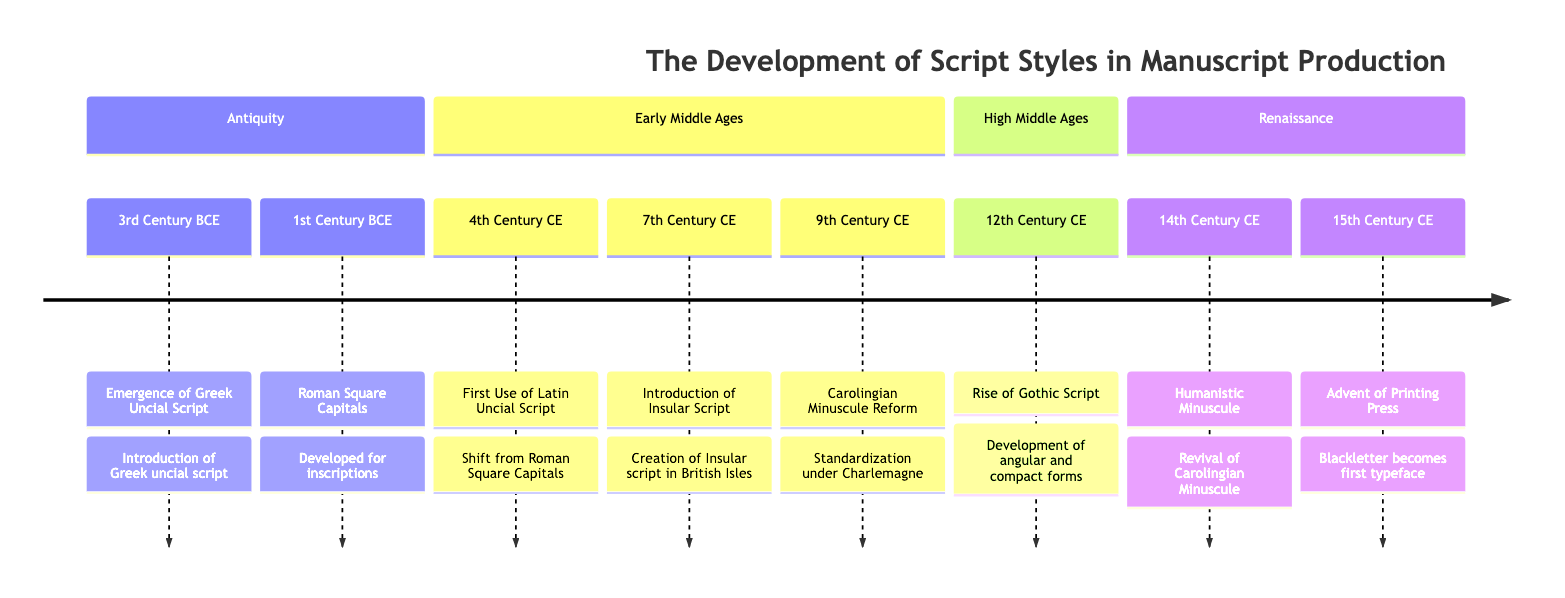What is the earliest script style mentioned in the timeline? The timeline lists the emergence of Greek Uncial Script in the 3rd Century BCE as the earliest event in the timeline. This can be confirmed by locating the earliest period in the timeline and reading the associated event.
Answer: Greek Uncial Script Which century does the Carolingian Minuscule Reform occur? The timeline identifies the Carolingian Minuscule Reform happening in the 9th Century CE. By scanning the events in the Early Middle Ages section, we find this specific event corresponds to that century.
Answer: 9th Century CE What type of script is prevalent during the High Middle Ages? The Rise of Gothic Script is the event that represents the prevalent script style during the High Middle Ages, as indicated in that section of the timeline.
Answer: Gothic Script How many major sections are there in the timeline? The timeline is divided into four major sections: Antiquity, Early Middle Ages, High Middle Ages, and Renaissance. Counting these sections provides the answer.
Answer: 4 What is the script style that led to modern Latin typefaces? According to the timeline, Humanistic Minuscule is identified as the script that is the basis for modern Latin typefaces during the Renaissance period. This is confirmed by referring to the appropriate event in the Renaissance section.
Answer: Humanistic Minuscule Which event marks the introduction of Insular Script? The timeline states that the Introduction of Insular Script occurs in the 7th Century CE. This event can be found by examining the Early Middle Ages section specifically for that detail.
Answer: Introduction of Insular Script In which century did the advent of the printing press occur? The timeline marks the advent of the printing press in the 15th Century CE. This can be corroborated by locating the relevant event in the Renaissance section of the timeline.
Answer: 15th Century CE What script style was used in illuminated manuscripts like the Book of Kells? The timeline highlights the Introduction of Insular Script in the 7th Century CE as primarily used in illuminated manuscripts, specifically mentioning the Book of Kells.
Answer: Insular Script 